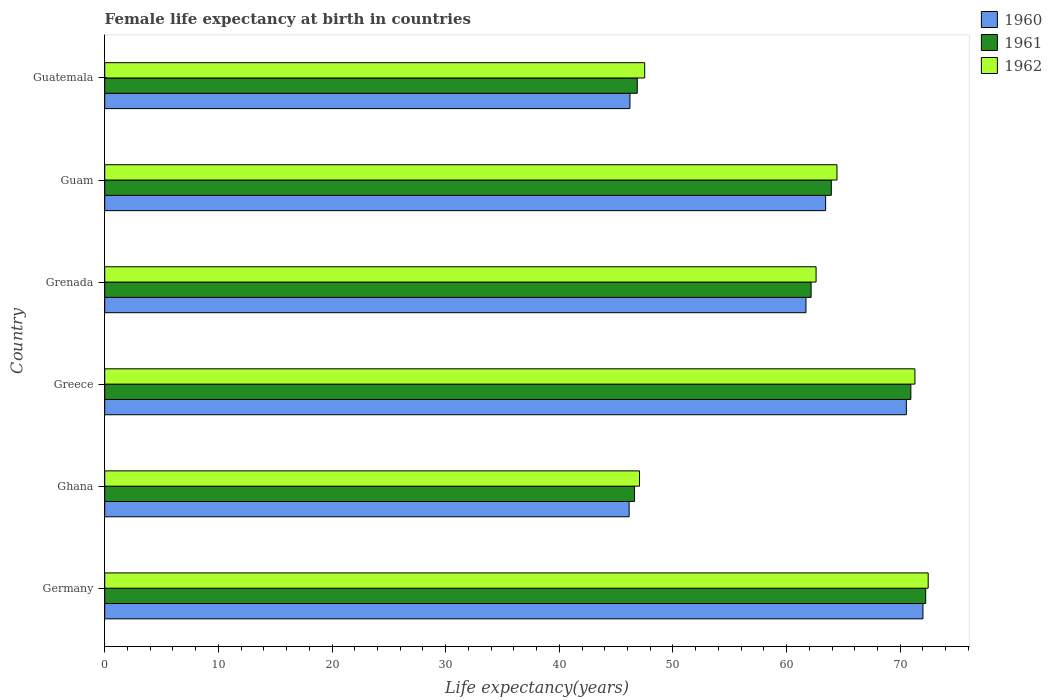How many different coloured bars are there?
Your response must be concise. 3. How many bars are there on the 6th tick from the top?
Offer a terse response. 3. How many bars are there on the 3rd tick from the bottom?
Ensure brevity in your answer.  3. What is the label of the 3rd group of bars from the top?
Provide a succinct answer. Grenada. In how many cases, is the number of bars for a given country not equal to the number of legend labels?
Provide a succinct answer. 0. What is the female life expectancy at birth in 1962 in Guam?
Provide a short and direct response. 64.44. Across all countries, what is the maximum female life expectancy at birth in 1961?
Your response must be concise. 72.24. Across all countries, what is the minimum female life expectancy at birth in 1962?
Your answer should be very brief. 47.06. In which country was the female life expectancy at birth in 1961 maximum?
Keep it short and to the point. Germany. In which country was the female life expectancy at birth in 1960 minimum?
Your answer should be compact. Ghana. What is the total female life expectancy at birth in 1962 in the graph?
Give a very brief answer. 365.37. What is the difference between the female life expectancy at birth in 1962 in Germany and that in Ghana?
Keep it short and to the point. 25.41. What is the difference between the female life expectancy at birth in 1961 in Guatemala and the female life expectancy at birth in 1960 in Guam?
Your answer should be compact. -16.58. What is the average female life expectancy at birth in 1960 per country?
Give a very brief answer. 60.01. What is the difference between the female life expectancy at birth in 1962 and female life expectancy at birth in 1960 in Guam?
Your answer should be very brief. 1. What is the ratio of the female life expectancy at birth in 1961 in Germany to that in Guatemala?
Provide a succinct answer. 1.54. Is the female life expectancy at birth in 1961 in Germany less than that in Greece?
Offer a terse response. No. Is the difference between the female life expectancy at birth in 1962 in Germany and Guatemala greater than the difference between the female life expectancy at birth in 1960 in Germany and Guatemala?
Offer a very short reply. No. What is the difference between the highest and the second highest female life expectancy at birth in 1961?
Ensure brevity in your answer.  1.31. What is the difference between the highest and the lowest female life expectancy at birth in 1961?
Provide a succinct answer. 25.63. Is the sum of the female life expectancy at birth in 1960 in Germany and Ghana greater than the maximum female life expectancy at birth in 1962 across all countries?
Your answer should be very brief. Yes. What does the 1st bar from the bottom in Germany represents?
Your answer should be very brief. 1960. Is it the case that in every country, the sum of the female life expectancy at birth in 1960 and female life expectancy at birth in 1961 is greater than the female life expectancy at birth in 1962?
Give a very brief answer. Yes. How many bars are there?
Provide a short and direct response. 18. How many countries are there in the graph?
Your response must be concise. 6. What is the difference between two consecutive major ticks on the X-axis?
Offer a very short reply. 10. Where does the legend appear in the graph?
Provide a short and direct response. Top right. How many legend labels are there?
Keep it short and to the point. 3. How are the legend labels stacked?
Your answer should be very brief. Vertical. What is the title of the graph?
Your response must be concise. Female life expectancy at birth in countries. What is the label or title of the X-axis?
Keep it short and to the point. Life expectancy(years). What is the label or title of the Y-axis?
Provide a short and direct response. Country. What is the Life expectancy(years) of 1960 in Germany?
Give a very brief answer. 72. What is the Life expectancy(years) of 1961 in Germany?
Provide a short and direct response. 72.24. What is the Life expectancy(years) in 1962 in Germany?
Provide a succinct answer. 72.46. What is the Life expectancy(years) in 1960 in Ghana?
Offer a very short reply. 46.15. What is the Life expectancy(years) of 1961 in Ghana?
Make the answer very short. 46.62. What is the Life expectancy(years) of 1962 in Ghana?
Offer a very short reply. 47.06. What is the Life expectancy(years) in 1960 in Greece?
Your response must be concise. 70.54. What is the Life expectancy(years) of 1961 in Greece?
Ensure brevity in your answer.  70.94. What is the Life expectancy(years) of 1962 in Greece?
Your answer should be compact. 71.3. What is the Life expectancy(years) of 1960 in Grenada?
Provide a short and direct response. 61.71. What is the Life expectancy(years) in 1961 in Grenada?
Make the answer very short. 62.16. What is the Life expectancy(years) in 1962 in Grenada?
Ensure brevity in your answer.  62.6. What is the Life expectancy(years) in 1960 in Guam?
Ensure brevity in your answer.  63.44. What is the Life expectancy(years) in 1961 in Guam?
Offer a very short reply. 63.94. What is the Life expectancy(years) of 1962 in Guam?
Provide a succinct answer. 64.44. What is the Life expectancy(years) of 1960 in Guatemala?
Provide a succinct answer. 46.22. What is the Life expectancy(years) of 1961 in Guatemala?
Offer a very short reply. 46.86. What is the Life expectancy(years) of 1962 in Guatemala?
Offer a terse response. 47.52. Across all countries, what is the maximum Life expectancy(years) in 1960?
Provide a short and direct response. 72. Across all countries, what is the maximum Life expectancy(years) in 1961?
Offer a very short reply. 72.24. Across all countries, what is the maximum Life expectancy(years) in 1962?
Offer a very short reply. 72.46. Across all countries, what is the minimum Life expectancy(years) of 1960?
Offer a very short reply. 46.15. Across all countries, what is the minimum Life expectancy(years) of 1961?
Offer a very short reply. 46.62. Across all countries, what is the minimum Life expectancy(years) of 1962?
Provide a short and direct response. 47.06. What is the total Life expectancy(years) in 1960 in the graph?
Offer a very short reply. 360.06. What is the total Life expectancy(years) in 1961 in the graph?
Keep it short and to the point. 362.75. What is the total Life expectancy(years) in 1962 in the graph?
Offer a very short reply. 365.37. What is the difference between the Life expectancy(years) in 1960 in Germany and that in Ghana?
Your answer should be compact. 25.86. What is the difference between the Life expectancy(years) of 1961 in Germany and that in Ghana?
Your answer should be compact. 25.63. What is the difference between the Life expectancy(years) of 1962 in Germany and that in Ghana?
Ensure brevity in your answer.  25.41. What is the difference between the Life expectancy(years) in 1960 in Germany and that in Greece?
Your response must be concise. 1.46. What is the difference between the Life expectancy(years) in 1961 in Germany and that in Greece?
Your answer should be very brief. 1.3. What is the difference between the Life expectancy(years) in 1962 in Germany and that in Greece?
Your response must be concise. 1.17. What is the difference between the Life expectancy(years) in 1960 in Germany and that in Grenada?
Provide a succinct answer. 10.29. What is the difference between the Life expectancy(years) in 1961 in Germany and that in Grenada?
Your answer should be compact. 10.08. What is the difference between the Life expectancy(years) of 1962 in Germany and that in Grenada?
Your answer should be compact. 9.87. What is the difference between the Life expectancy(years) in 1960 in Germany and that in Guam?
Make the answer very short. 8.56. What is the difference between the Life expectancy(years) in 1961 in Germany and that in Guam?
Give a very brief answer. 8.3. What is the difference between the Life expectancy(years) in 1962 in Germany and that in Guam?
Keep it short and to the point. 8.03. What is the difference between the Life expectancy(years) of 1960 in Germany and that in Guatemala?
Give a very brief answer. 25.78. What is the difference between the Life expectancy(years) in 1961 in Germany and that in Guatemala?
Your answer should be compact. 25.38. What is the difference between the Life expectancy(years) in 1962 in Germany and that in Guatemala?
Your answer should be very brief. 24.95. What is the difference between the Life expectancy(years) of 1960 in Ghana and that in Greece?
Ensure brevity in your answer.  -24.39. What is the difference between the Life expectancy(years) of 1961 in Ghana and that in Greece?
Provide a succinct answer. -24.32. What is the difference between the Life expectancy(years) of 1962 in Ghana and that in Greece?
Offer a very short reply. -24.24. What is the difference between the Life expectancy(years) of 1960 in Ghana and that in Grenada?
Provide a succinct answer. -15.56. What is the difference between the Life expectancy(years) of 1961 in Ghana and that in Grenada?
Your answer should be very brief. -15.54. What is the difference between the Life expectancy(years) in 1962 in Ghana and that in Grenada?
Your response must be concise. -15.54. What is the difference between the Life expectancy(years) in 1960 in Ghana and that in Guam?
Provide a short and direct response. -17.29. What is the difference between the Life expectancy(years) in 1961 in Ghana and that in Guam?
Give a very brief answer. -17.32. What is the difference between the Life expectancy(years) of 1962 in Ghana and that in Guam?
Your response must be concise. -17.38. What is the difference between the Life expectancy(years) of 1960 in Ghana and that in Guatemala?
Offer a terse response. -0.07. What is the difference between the Life expectancy(years) of 1961 in Ghana and that in Guatemala?
Provide a succinct answer. -0.25. What is the difference between the Life expectancy(years) in 1962 in Ghana and that in Guatemala?
Provide a succinct answer. -0.46. What is the difference between the Life expectancy(years) in 1960 in Greece and that in Grenada?
Provide a short and direct response. 8.83. What is the difference between the Life expectancy(years) of 1961 in Greece and that in Grenada?
Your response must be concise. 8.78. What is the difference between the Life expectancy(years) of 1962 in Greece and that in Grenada?
Keep it short and to the point. 8.7. What is the difference between the Life expectancy(years) of 1960 in Greece and that in Guam?
Offer a terse response. 7.1. What is the difference between the Life expectancy(years) of 1961 in Greece and that in Guam?
Provide a short and direct response. 7. What is the difference between the Life expectancy(years) in 1962 in Greece and that in Guam?
Your answer should be very brief. 6.86. What is the difference between the Life expectancy(years) in 1960 in Greece and that in Guatemala?
Your answer should be very brief. 24.32. What is the difference between the Life expectancy(years) in 1961 in Greece and that in Guatemala?
Offer a terse response. 24.07. What is the difference between the Life expectancy(years) in 1962 in Greece and that in Guatemala?
Give a very brief answer. 23.78. What is the difference between the Life expectancy(years) of 1960 in Grenada and that in Guam?
Keep it short and to the point. -1.73. What is the difference between the Life expectancy(years) of 1961 in Grenada and that in Guam?
Your response must be concise. -1.78. What is the difference between the Life expectancy(years) of 1962 in Grenada and that in Guam?
Provide a short and direct response. -1.84. What is the difference between the Life expectancy(years) of 1960 in Grenada and that in Guatemala?
Ensure brevity in your answer.  15.49. What is the difference between the Life expectancy(years) in 1961 in Grenada and that in Guatemala?
Provide a short and direct response. 15.3. What is the difference between the Life expectancy(years) of 1962 in Grenada and that in Guatemala?
Make the answer very short. 15.08. What is the difference between the Life expectancy(years) in 1960 in Guam and that in Guatemala?
Make the answer very short. 17.22. What is the difference between the Life expectancy(years) of 1961 in Guam and that in Guatemala?
Provide a succinct answer. 17.08. What is the difference between the Life expectancy(years) in 1962 in Guam and that in Guatemala?
Offer a terse response. 16.92. What is the difference between the Life expectancy(years) of 1960 in Germany and the Life expectancy(years) of 1961 in Ghana?
Offer a terse response. 25.39. What is the difference between the Life expectancy(years) of 1960 in Germany and the Life expectancy(years) of 1962 in Ghana?
Your response must be concise. 24.94. What is the difference between the Life expectancy(years) in 1961 in Germany and the Life expectancy(years) in 1962 in Ghana?
Offer a very short reply. 25.18. What is the difference between the Life expectancy(years) of 1960 in Germany and the Life expectancy(years) of 1961 in Greece?
Your answer should be compact. 1.07. What is the difference between the Life expectancy(years) of 1960 in Germany and the Life expectancy(years) of 1962 in Greece?
Ensure brevity in your answer.  0.71. What is the difference between the Life expectancy(years) of 1961 in Germany and the Life expectancy(years) of 1962 in Greece?
Your answer should be compact. 0.95. What is the difference between the Life expectancy(years) of 1960 in Germany and the Life expectancy(years) of 1961 in Grenada?
Your answer should be compact. 9.84. What is the difference between the Life expectancy(years) in 1960 in Germany and the Life expectancy(years) in 1962 in Grenada?
Provide a succinct answer. 9.4. What is the difference between the Life expectancy(years) of 1961 in Germany and the Life expectancy(years) of 1962 in Grenada?
Ensure brevity in your answer.  9.64. What is the difference between the Life expectancy(years) in 1960 in Germany and the Life expectancy(years) in 1961 in Guam?
Ensure brevity in your answer.  8.06. What is the difference between the Life expectancy(years) in 1960 in Germany and the Life expectancy(years) in 1962 in Guam?
Give a very brief answer. 7.57. What is the difference between the Life expectancy(years) of 1961 in Germany and the Life expectancy(years) of 1962 in Guam?
Provide a short and direct response. 7.8. What is the difference between the Life expectancy(years) in 1960 in Germany and the Life expectancy(years) in 1961 in Guatemala?
Offer a terse response. 25.14. What is the difference between the Life expectancy(years) in 1960 in Germany and the Life expectancy(years) in 1962 in Guatemala?
Make the answer very short. 24.49. What is the difference between the Life expectancy(years) of 1961 in Germany and the Life expectancy(years) of 1962 in Guatemala?
Provide a short and direct response. 24.73. What is the difference between the Life expectancy(years) in 1960 in Ghana and the Life expectancy(years) in 1961 in Greece?
Your answer should be compact. -24.79. What is the difference between the Life expectancy(years) of 1960 in Ghana and the Life expectancy(years) of 1962 in Greece?
Your answer should be very brief. -25.15. What is the difference between the Life expectancy(years) in 1961 in Ghana and the Life expectancy(years) in 1962 in Greece?
Provide a short and direct response. -24.68. What is the difference between the Life expectancy(years) of 1960 in Ghana and the Life expectancy(years) of 1961 in Grenada?
Provide a succinct answer. -16.01. What is the difference between the Life expectancy(years) in 1960 in Ghana and the Life expectancy(years) in 1962 in Grenada?
Keep it short and to the point. -16.45. What is the difference between the Life expectancy(years) in 1961 in Ghana and the Life expectancy(years) in 1962 in Grenada?
Provide a short and direct response. -15.98. What is the difference between the Life expectancy(years) in 1960 in Ghana and the Life expectancy(years) in 1961 in Guam?
Provide a succinct answer. -17.79. What is the difference between the Life expectancy(years) in 1960 in Ghana and the Life expectancy(years) in 1962 in Guam?
Provide a succinct answer. -18.29. What is the difference between the Life expectancy(years) in 1961 in Ghana and the Life expectancy(years) in 1962 in Guam?
Your answer should be compact. -17.82. What is the difference between the Life expectancy(years) of 1960 in Ghana and the Life expectancy(years) of 1961 in Guatemala?
Provide a short and direct response. -0.71. What is the difference between the Life expectancy(years) of 1960 in Ghana and the Life expectancy(years) of 1962 in Guatemala?
Make the answer very short. -1.37. What is the difference between the Life expectancy(years) in 1961 in Ghana and the Life expectancy(years) in 1962 in Guatemala?
Ensure brevity in your answer.  -0.9. What is the difference between the Life expectancy(years) in 1960 in Greece and the Life expectancy(years) in 1961 in Grenada?
Keep it short and to the point. 8.38. What is the difference between the Life expectancy(years) in 1960 in Greece and the Life expectancy(years) in 1962 in Grenada?
Provide a succinct answer. 7.94. What is the difference between the Life expectancy(years) in 1961 in Greece and the Life expectancy(years) in 1962 in Grenada?
Offer a terse response. 8.34. What is the difference between the Life expectancy(years) of 1960 in Greece and the Life expectancy(years) of 1961 in Guam?
Ensure brevity in your answer.  6.6. What is the difference between the Life expectancy(years) in 1960 in Greece and the Life expectancy(years) in 1962 in Guam?
Your answer should be compact. 6.1. What is the difference between the Life expectancy(years) of 1960 in Greece and the Life expectancy(years) of 1961 in Guatemala?
Offer a very short reply. 23.68. What is the difference between the Life expectancy(years) in 1960 in Greece and the Life expectancy(years) in 1962 in Guatemala?
Ensure brevity in your answer.  23.02. What is the difference between the Life expectancy(years) in 1961 in Greece and the Life expectancy(years) in 1962 in Guatemala?
Provide a short and direct response. 23.42. What is the difference between the Life expectancy(years) in 1960 in Grenada and the Life expectancy(years) in 1961 in Guam?
Your answer should be compact. -2.23. What is the difference between the Life expectancy(years) of 1960 in Grenada and the Life expectancy(years) of 1962 in Guam?
Give a very brief answer. -2.73. What is the difference between the Life expectancy(years) of 1961 in Grenada and the Life expectancy(years) of 1962 in Guam?
Ensure brevity in your answer.  -2.28. What is the difference between the Life expectancy(years) of 1960 in Grenada and the Life expectancy(years) of 1961 in Guatemala?
Offer a terse response. 14.85. What is the difference between the Life expectancy(years) of 1960 in Grenada and the Life expectancy(years) of 1962 in Guatemala?
Keep it short and to the point. 14.19. What is the difference between the Life expectancy(years) of 1961 in Grenada and the Life expectancy(years) of 1962 in Guatemala?
Keep it short and to the point. 14.64. What is the difference between the Life expectancy(years) of 1960 in Guam and the Life expectancy(years) of 1961 in Guatemala?
Your answer should be very brief. 16.58. What is the difference between the Life expectancy(years) of 1960 in Guam and the Life expectancy(years) of 1962 in Guatemala?
Ensure brevity in your answer.  15.92. What is the difference between the Life expectancy(years) in 1961 in Guam and the Life expectancy(years) in 1962 in Guatemala?
Offer a terse response. 16.42. What is the average Life expectancy(years) of 1960 per country?
Your answer should be very brief. 60.01. What is the average Life expectancy(years) in 1961 per country?
Keep it short and to the point. 60.46. What is the average Life expectancy(years) of 1962 per country?
Keep it short and to the point. 60.9. What is the difference between the Life expectancy(years) of 1960 and Life expectancy(years) of 1961 in Germany?
Provide a short and direct response. -0.24. What is the difference between the Life expectancy(years) of 1960 and Life expectancy(years) of 1962 in Germany?
Your answer should be very brief. -0.46. What is the difference between the Life expectancy(years) in 1961 and Life expectancy(years) in 1962 in Germany?
Keep it short and to the point. -0.22. What is the difference between the Life expectancy(years) in 1960 and Life expectancy(years) in 1961 in Ghana?
Give a very brief answer. -0.47. What is the difference between the Life expectancy(years) in 1960 and Life expectancy(years) in 1962 in Ghana?
Provide a succinct answer. -0.91. What is the difference between the Life expectancy(years) of 1961 and Life expectancy(years) of 1962 in Ghana?
Your answer should be compact. -0.44. What is the difference between the Life expectancy(years) in 1960 and Life expectancy(years) in 1961 in Greece?
Keep it short and to the point. -0.4. What is the difference between the Life expectancy(years) in 1960 and Life expectancy(years) in 1962 in Greece?
Give a very brief answer. -0.76. What is the difference between the Life expectancy(years) of 1961 and Life expectancy(years) of 1962 in Greece?
Ensure brevity in your answer.  -0.36. What is the difference between the Life expectancy(years) of 1960 and Life expectancy(years) of 1961 in Grenada?
Ensure brevity in your answer.  -0.45. What is the difference between the Life expectancy(years) of 1960 and Life expectancy(years) of 1962 in Grenada?
Keep it short and to the point. -0.89. What is the difference between the Life expectancy(years) of 1961 and Life expectancy(years) of 1962 in Grenada?
Your response must be concise. -0.44. What is the difference between the Life expectancy(years) in 1960 and Life expectancy(years) in 1961 in Guam?
Ensure brevity in your answer.  -0.5. What is the difference between the Life expectancy(years) of 1960 and Life expectancy(years) of 1962 in Guam?
Offer a terse response. -1. What is the difference between the Life expectancy(years) of 1961 and Life expectancy(years) of 1962 in Guam?
Your response must be concise. -0.5. What is the difference between the Life expectancy(years) of 1960 and Life expectancy(years) of 1961 in Guatemala?
Provide a short and direct response. -0.64. What is the difference between the Life expectancy(years) of 1960 and Life expectancy(years) of 1962 in Guatemala?
Your answer should be very brief. -1.3. What is the difference between the Life expectancy(years) in 1961 and Life expectancy(years) in 1962 in Guatemala?
Give a very brief answer. -0.65. What is the ratio of the Life expectancy(years) of 1960 in Germany to that in Ghana?
Give a very brief answer. 1.56. What is the ratio of the Life expectancy(years) in 1961 in Germany to that in Ghana?
Make the answer very short. 1.55. What is the ratio of the Life expectancy(years) of 1962 in Germany to that in Ghana?
Offer a terse response. 1.54. What is the ratio of the Life expectancy(years) in 1960 in Germany to that in Greece?
Your answer should be compact. 1.02. What is the ratio of the Life expectancy(years) in 1961 in Germany to that in Greece?
Ensure brevity in your answer.  1.02. What is the ratio of the Life expectancy(years) in 1962 in Germany to that in Greece?
Your response must be concise. 1.02. What is the ratio of the Life expectancy(years) of 1960 in Germany to that in Grenada?
Provide a succinct answer. 1.17. What is the ratio of the Life expectancy(years) of 1961 in Germany to that in Grenada?
Offer a very short reply. 1.16. What is the ratio of the Life expectancy(years) in 1962 in Germany to that in Grenada?
Provide a short and direct response. 1.16. What is the ratio of the Life expectancy(years) of 1960 in Germany to that in Guam?
Your answer should be very brief. 1.14. What is the ratio of the Life expectancy(years) of 1961 in Germany to that in Guam?
Keep it short and to the point. 1.13. What is the ratio of the Life expectancy(years) in 1962 in Germany to that in Guam?
Provide a short and direct response. 1.12. What is the ratio of the Life expectancy(years) in 1960 in Germany to that in Guatemala?
Give a very brief answer. 1.56. What is the ratio of the Life expectancy(years) of 1961 in Germany to that in Guatemala?
Your response must be concise. 1.54. What is the ratio of the Life expectancy(years) in 1962 in Germany to that in Guatemala?
Ensure brevity in your answer.  1.52. What is the ratio of the Life expectancy(years) of 1960 in Ghana to that in Greece?
Ensure brevity in your answer.  0.65. What is the ratio of the Life expectancy(years) of 1961 in Ghana to that in Greece?
Provide a short and direct response. 0.66. What is the ratio of the Life expectancy(years) of 1962 in Ghana to that in Greece?
Make the answer very short. 0.66. What is the ratio of the Life expectancy(years) of 1960 in Ghana to that in Grenada?
Your answer should be compact. 0.75. What is the ratio of the Life expectancy(years) in 1961 in Ghana to that in Grenada?
Your answer should be compact. 0.75. What is the ratio of the Life expectancy(years) of 1962 in Ghana to that in Grenada?
Provide a succinct answer. 0.75. What is the ratio of the Life expectancy(years) in 1960 in Ghana to that in Guam?
Make the answer very short. 0.73. What is the ratio of the Life expectancy(years) in 1961 in Ghana to that in Guam?
Offer a very short reply. 0.73. What is the ratio of the Life expectancy(years) of 1962 in Ghana to that in Guam?
Provide a short and direct response. 0.73. What is the ratio of the Life expectancy(years) in 1960 in Ghana to that in Guatemala?
Provide a short and direct response. 1. What is the ratio of the Life expectancy(years) of 1960 in Greece to that in Grenada?
Offer a terse response. 1.14. What is the ratio of the Life expectancy(years) of 1961 in Greece to that in Grenada?
Your response must be concise. 1.14. What is the ratio of the Life expectancy(years) of 1962 in Greece to that in Grenada?
Your answer should be very brief. 1.14. What is the ratio of the Life expectancy(years) of 1960 in Greece to that in Guam?
Make the answer very short. 1.11. What is the ratio of the Life expectancy(years) in 1961 in Greece to that in Guam?
Your answer should be very brief. 1.11. What is the ratio of the Life expectancy(years) in 1962 in Greece to that in Guam?
Offer a terse response. 1.11. What is the ratio of the Life expectancy(years) of 1960 in Greece to that in Guatemala?
Your answer should be very brief. 1.53. What is the ratio of the Life expectancy(years) in 1961 in Greece to that in Guatemala?
Give a very brief answer. 1.51. What is the ratio of the Life expectancy(years) of 1962 in Greece to that in Guatemala?
Your answer should be compact. 1.5. What is the ratio of the Life expectancy(years) in 1960 in Grenada to that in Guam?
Ensure brevity in your answer.  0.97. What is the ratio of the Life expectancy(years) in 1961 in Grenada to that in Guam?
Keep it short and to the point. 0.97. What is the ratio of the Life expectancy(years) of 1962 in Grenada to that in Guam?
Give a very brief answer. 0.97. What is the ratio of the Life expectancy(years) in 1960 in Grenada to that in Guatemala?
Provide a succinct answer. 1.34. What is the ratio of the Life expectancy(years) of 1961 in Grenada to that in Guatemala?
Offer a very short reply. 1.33. What is the ratio of the Life expectancy(years) of 1962 in Grenada to that in Guatemala?
Offer a very short reply. 1.32. What is the ratio of the Life expectancy(years) in 1960 in Guam to that in Guatemala?
Provide a succinct answer. 1.37. What is the ratio of the Life expectancy(years) of 1961 in Guam to that in Guatemala?
Give a very brief answer. 1.36. What is the ratio of the Life expectancy(years) of 1962 in Guam to that in Guatemala?
Provide a short and direct response. 1.36. What is the difference between the highest and the second highest Life expectancy(years) in 1960?
Keep it short and to the point. 1.46. What is the difference between the highest and the second highest Life expectancy(years) of 1961?
Provide a succinct answer. 1.3. What is the difference between the highest and the second highest Life expectancy(years) in 1962?
Your response must be concise. 1.17. What is the difference between the highest and the lowest Life expectancy(years) of 1960?
Give a very brief answer. 25.86. What is the difference between the highest and the lowest Life expectancy(years) of 1961?
Offer a very short reply. 25.63. What is the difference between the highest and the lowest Life expectancy(years) in 1962?
Give a very brief answer. 25.41. 